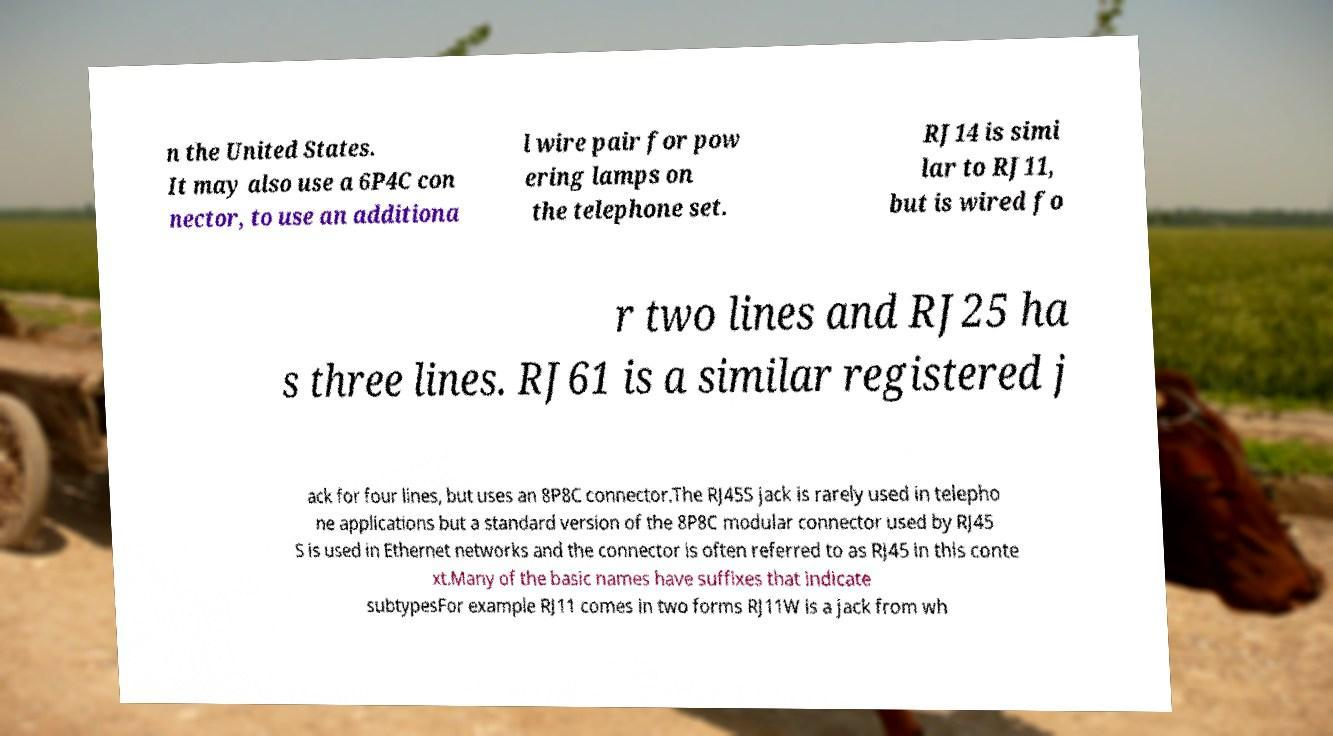There's text embedded in this image that I need extracted. Can you transcribe it verbatim? n the United States. It may also use a 6P4C con nector, to use an additiona l wire pair for pow ering lamps on the telephone set. RJ14 is simi lar to RJ11, but is wired fo r two lines and RJ25 ha s three lines. RJ61 is a similar registered j ack for four lines, but uses an 8P8C connector.The RJ45S jack is rarely used in telepho ne applications but a standard version of the 8P8C modular connector used by RJ45 S is used in Ethernet networks and the connector is often referred to as RJ45 in this conte xt.Many of the basic names have suffixes that indicate subtypesFor example RJ11 comes in two forms RJ11W is a jack from wh 